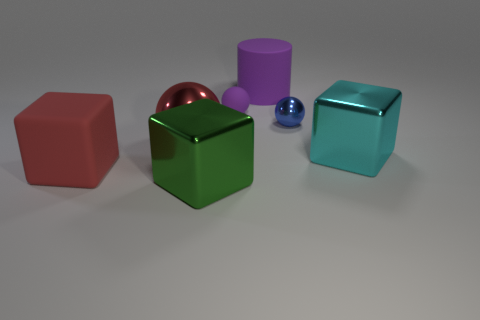The object that is the same color as the rubber block is what shape?
Your answer should be compact. Sphere. What is the size of the shiny block right of the tiny purple sphere?
Offer a very short reply. Large. Does the rubber cylinder have the same color as the ball to the right of the small purple rubber thing?
Your response must be concise. No. How many other objects are the same material as the blue thing?
Your answer should be compact. 3. Are there more small objects than large red spheres?
Provide a short and direct response. Yes. Is the color of the metal ball behind the red sphere the same as the large metal ball?
Your answer should be very brief. No. The large cylinder has what color?
Ensure brevity in your answer.  Purple. There is a matte thing that is in front of the big cyan metal object; are there any tiny purple things left of it?
Keep it short and to the point. No. What is the shape of the purple rubber object in front of the rubber thing to the right of the purple matte ball?
Make the answer very short. Sphere. Is the number of big metal cubes less than the number of purple matte balls?
Offer a very short reply. No. 